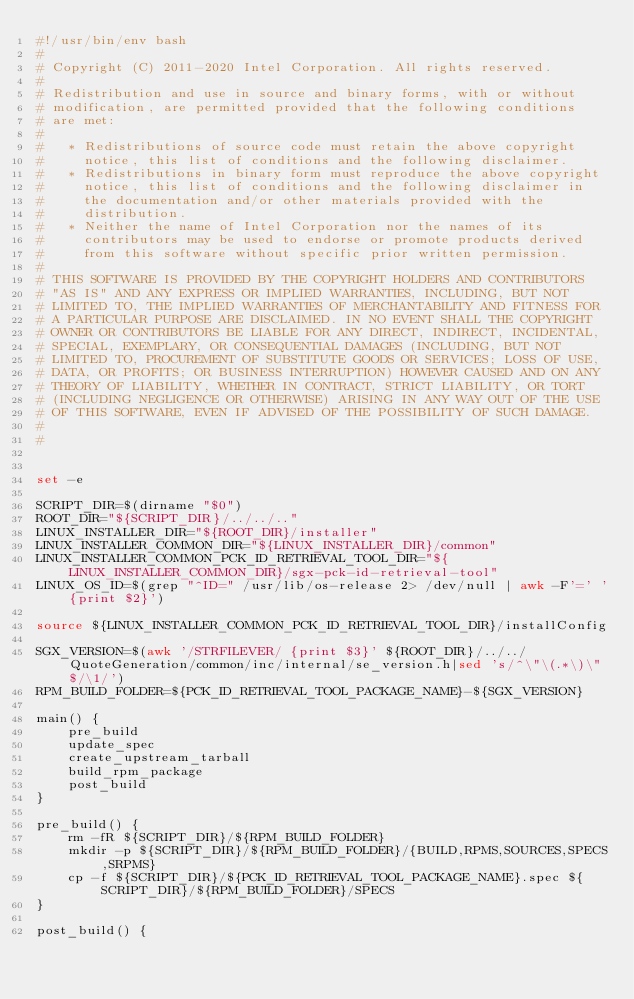Convert code to text. <code><loc_0><loc_0><loc_500><loc_500><_Bash_>#!/usr/bin/env bash
#
# Copyright (C) 2011-2020 Intel Corporation. All rights reserved.
#
# Redistribution and use in source and binary forms, with or without
# modification, are permitted provided that the following conditions
# are met:
#
#   * Redistributions of source code must retain the above copyright
#     notice, this list of conditions and the following disclaimer.
#   * Redistributions in binary form must reproduce the above copyright
#     notice, this list of conditions and the following disclaimer in
#     the documentation and/or other materials provided with the
#     distribution.
#   * Neither the name of Intel Corporation nor the names of its
#     contributors may be used to endorse or promote products derived
#     from this software without specific prior written permission.
#
# THIS SOFTWARE IS PROVIDED BY THE COPYRIGHT HOLDERS AND CONTRIBUTORS
# "AS IS" AND ANY EXPRESS OR IMPLIED WARRANTIES, INCLUDING, BUT NOT
# LIMITED TO, THE IMPLIED WARRANTIES OF MERCHANTABILITY AND FITNESS FOR
# A PARTICULAR PURPOSE ARE DISCLAIMED. IN NO EVENT SHALL THE COPYRIGHT
# OWNER OR CONTRIBUTORS BE LIABLE FOR ANY DIRECT, INDIRECT, INCIDENTAL,
# SPECIAL, EXEMPLARY, OR CONSEQUENTIAL DAMAGES (INCLUDING, BUT NOT
# LIMITED TO, PROCUREMENT OF SUBSTITUTE GOODS OR SERVICES; LOSS OF USE,
# DATA, OR PROFITS; OR BUSINESS INTERRUPTION) HOWEVER CAUSED AND ON ANY
# THEORY OF LIABILITY, WHETHER IN CONTRACT, STRICT LIABILITY, OR TORT
# (INCLUDING NEGLIGENCE OR OTHERWISE) ARISING IN ANY WAY OUT OF THE USE
# OF THIS SOFTWARE, EVEN IF ADVISED OF THE POSSIBILITY OF SUCH DAMAGE.
#
#


set -e

SCRIPT_DIR=$(dirname "$0")
ROOT_DIR="${SCRIPT_DIR}/../../.."
LINUX_INSTALLER_DIR="${ROOT_DIR}/installer"
LINUX_INSTALLER_COMMON_DIR="${LINUX_INSTALLER_DIR}/common"
LINUX_INSTALLER_COMMON_PCK_ID_RETRIEVAL_TOOL_DIR="${LINUX_INSTALLER_COMMON_DIR}/sgx-pck-id-retrieval-tool"
LINUX_OS_ID=$(grep "^ID=" /usr/lib/os-release 2> /dev/null | awk -F'=' '{print $2}')

source ${LINUX_INSTALLER_COMMON_PCK_ID_RETRIEVAL_TOOL_DIR}/installConfig

SGX_VERSION=$(awk '/STRFILEVER/ {print $3}' ${ROOT_DIR}/../../QuoteGeneration/common/inc/internal/se_version.h|sed 's/^\"\(.*\)\"$/\1/')
RPM_BUILD_FOLDER=${PCK_ID_RETRIEVAL_TOOL_PACKAGE_NAME}-${SGX_VERSION}

main() {
    pre_build
    update_spec
    create_upstream_tarball
    build_rpm_package
    post_build
}

pre_build() {
    rm -fR ${SCRIPT_DIR}/${RPM_BUILD_FOLDER}
    mkdir -p ${SCRIPT_DIR}/${RPM_BUILD_FOLDER}/{BUILD,RPMS,SOURCES,SPECS,SRPMS}
    cp -f ${SCRIPT_DIR}/${PCK_ID_RETRIEVAL_TOOL_PACKAGE_NAME}.spec ${SCRIPT_DIR}/${RPM_BUILD_FOLDER}/SPECS
}

post_build() {</code> 